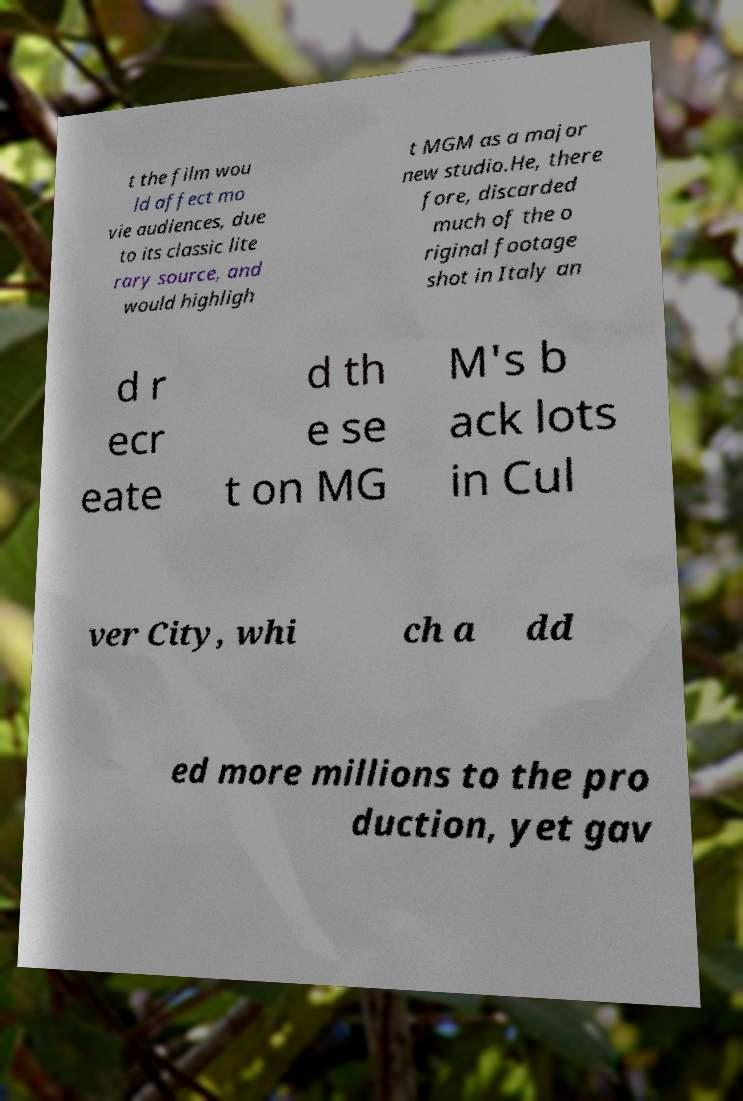What messages or text are displayed in this image? I need them in a readable, typed format. t the film wou ld affect mo vie audiences, due to its classic lite rary source, and would highligh t MGM as a major new studio.He, there fore, discarded much of the o riginal footage shot in Italy an d r ecr eate d th e se t on MG M's b ack lots in Cul ver City, whi ch a dd ed more millions to the pro duction, yet gav 